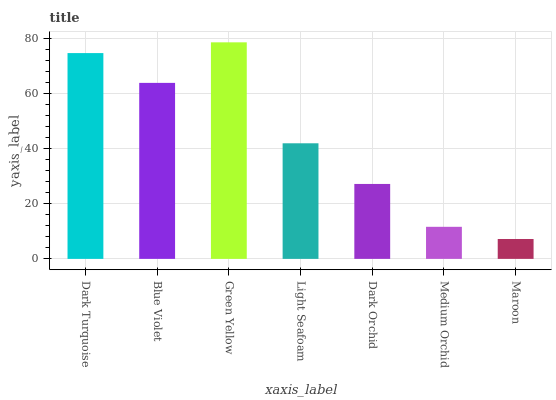Is Blue Violet the minimum?
Answer yes or no. No. Is Blue Violet the maximum?
Answer yes or no. No. Is Dark Turquoise greater than Blue Violet?
Answer yes or no. Yes. Is Blue Violet less than Dark Turquoise?
Answer yes or no. Yes. Is Blue Violet greater than Dark Turquoise?
Answer yes or no. No. Is Dark Turquoise less than Blue Violet?
Answer yes or no. No. Is Light Seafoam the high median?
Answer yes or no. Yes. Is Light Seafoam the low median?
Answer yes or no. Yes. Is Dark Turquoise the high median?
Answer yes or no. No. Is Maroon the low median?
Answer yes or no. No. 